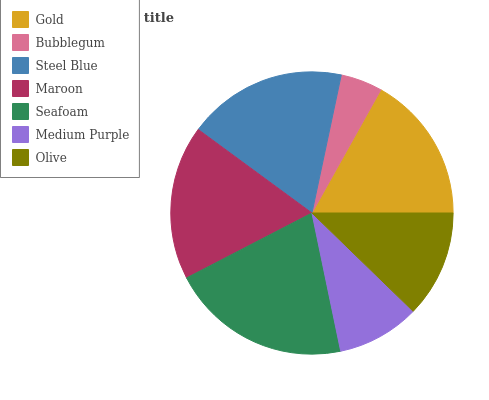Is Bubblegum the minimum?
Answer yes or no. Yes. Is Seafoam the maximum?
Answer yes or no. Yes. Is Steel Blue the minimum?
Answer yes or no. No. Is Steel Blue the maximum?
Answer yes or no. No. Is Steel Blue greater than Bubblegum?
Answer yes or no. Yes. Is Bubblegum less than Steel Blue?
Answer yes or no. Yes. Is Bubblegum greater than Steel Blue?
Answer yes or no. No. Is Steel Blue less than Bubblegum?
Answer yes or no. No. Is Gold the high median?
Answer yes or no. Yes. Is Gold the low median?
Answer yes or no. Yes. Is Maroon the high median?
Answer yes or no. No. Is Medium Purple the low median?
Answer yes or no. No. 